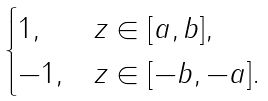Convert formula to latex. <formula><loc_0><loc_0><loc_500><loc_500>\begin{cases} 1 , & z \in [ a , b ] , \\ - 1 , & z \in [ - b , - a ] . \end{cases}</formula> 